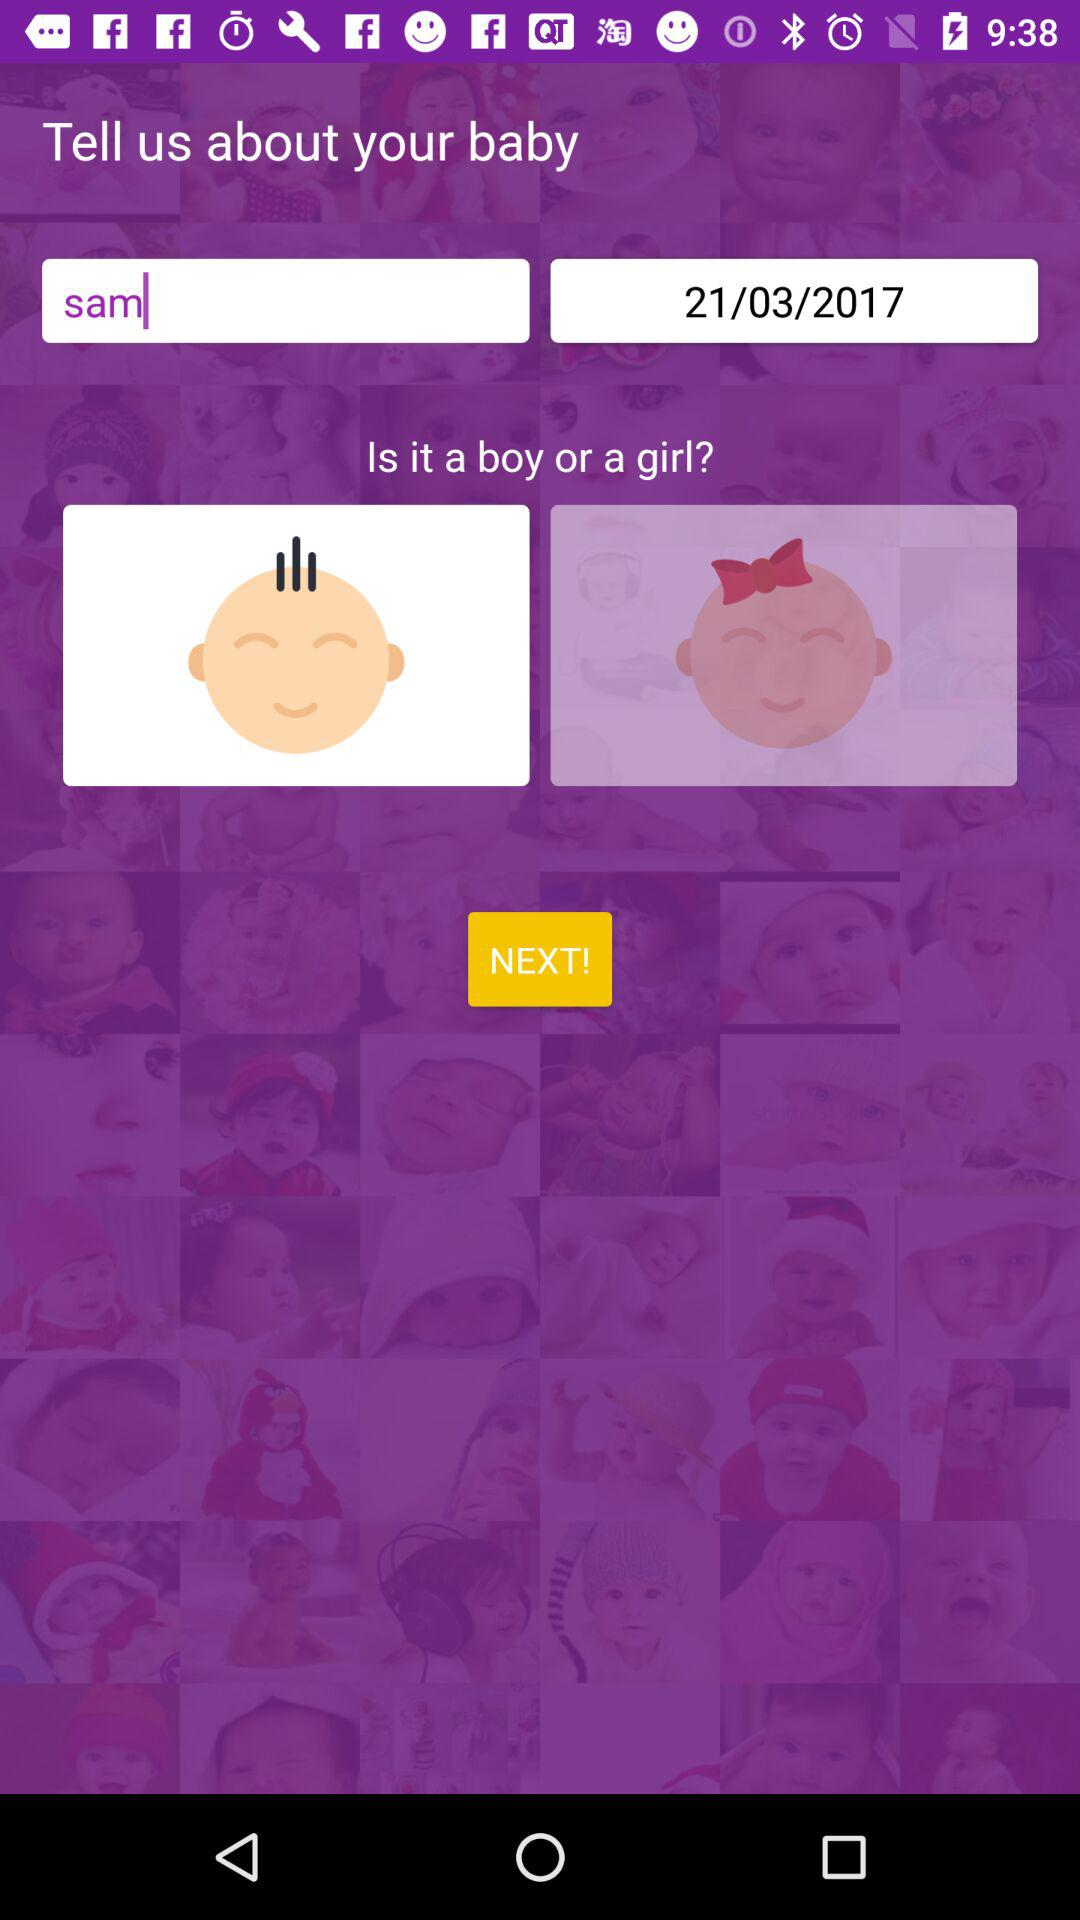What is the date? The date is March 21, 2017. 